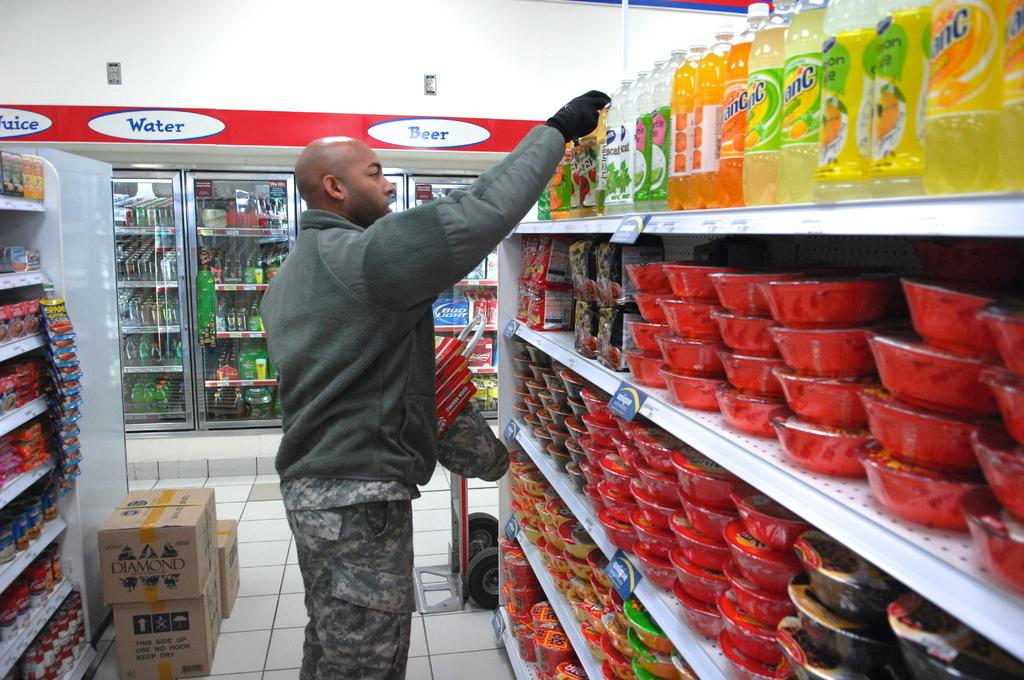Provide a one-sentence caption for the provided image. A man is picking items off the grocery store shelf's near the beer section. 